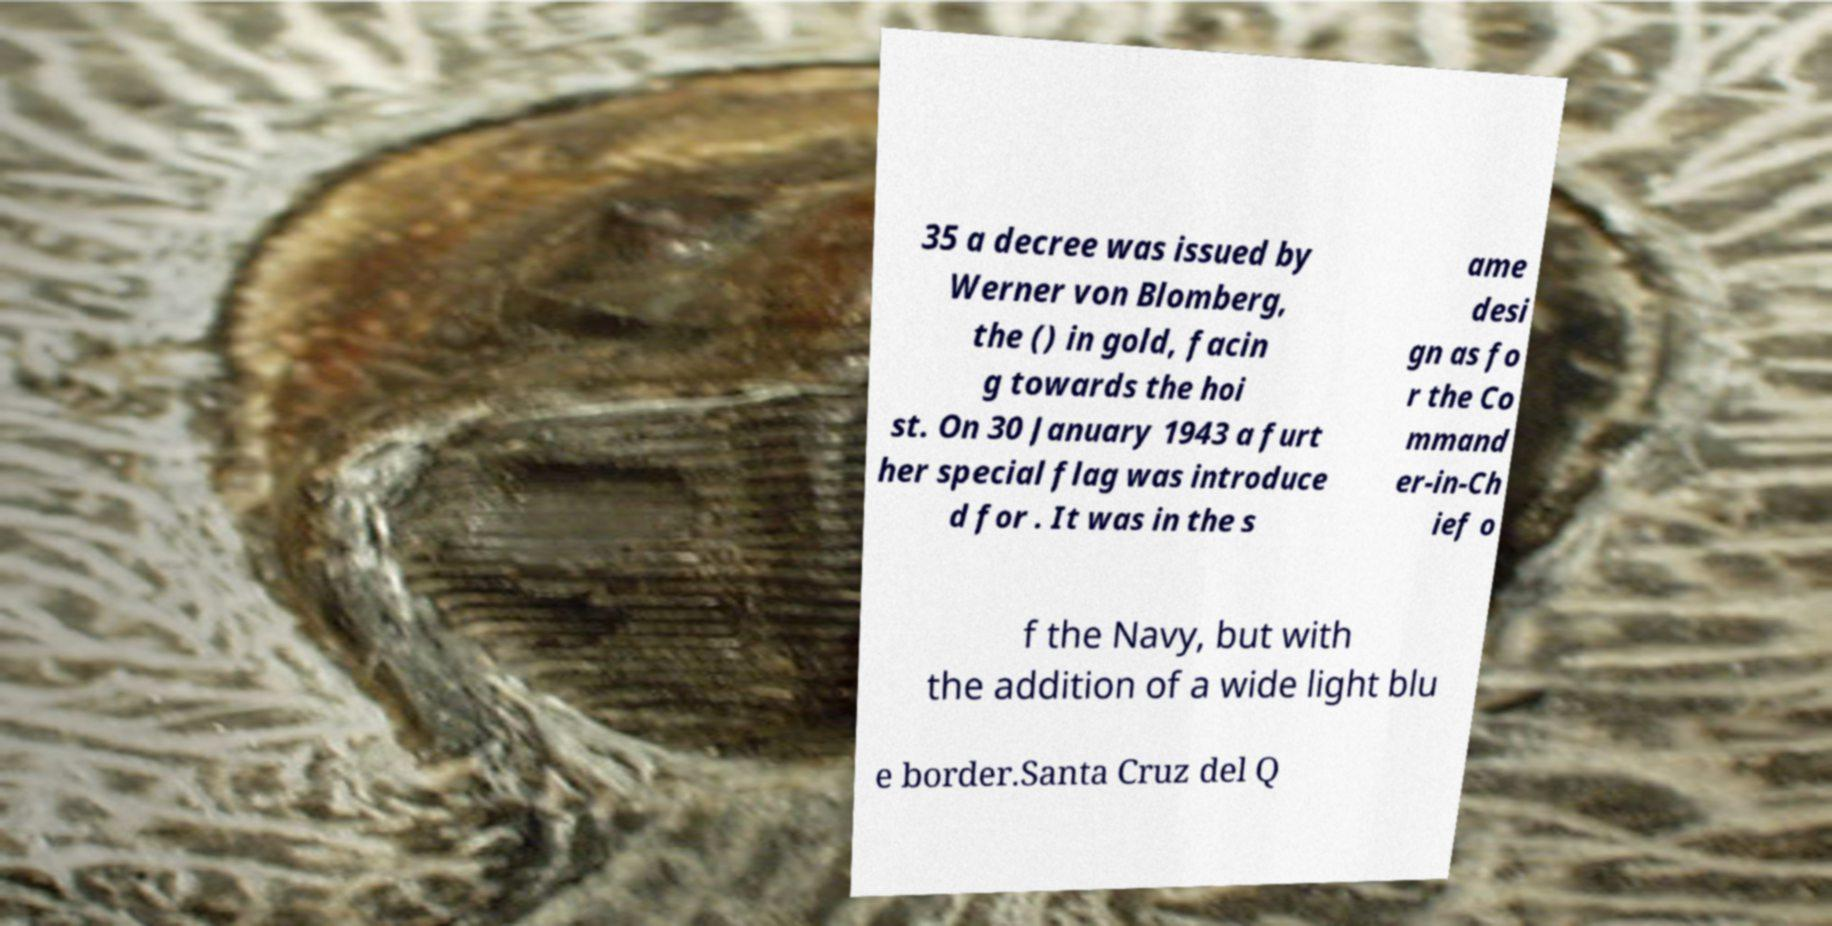Can you read and provide the text displayed in the image?This photo seems to have some interesting text. Can you extract and type it out for me? 35 a decree was issued by Werner von Blomberg, the () in gold, facin g towards the hoi st. On 30 January 1943 a furt her special flag was introduce d for . It was in the s ame desi gn as fo r the Co mmand er-in-Ch ief o f the Navy, but with the addition of a wide light blu e border.Santa Cruz del Q 